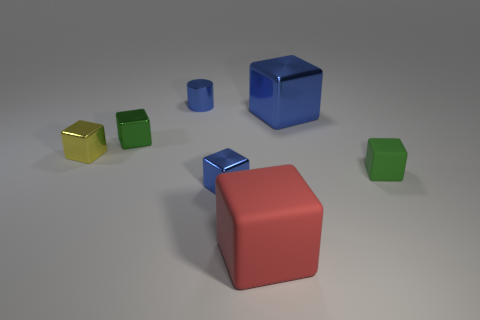Subtract all big red blocks. How many blocks are left? 5 Subtract all green cubes. How many cubes are left? 4 Subtract all gray blocks. Subtract all purple cylinders. How many blocks are left? 6 Add 3 big gray objects. How many objects exist? 10 Subtract all blocks. How many objects are left? 1 Subtract 1 red cubes. How many objects are left? 6 Subtract all small blue objects. Subtract all big cyan cylinders. How many objects are left? 5 Add 6 large matte things. How many large matte things are left? 7 Add 2 small yellow things. How many small yellow things exist? 3 